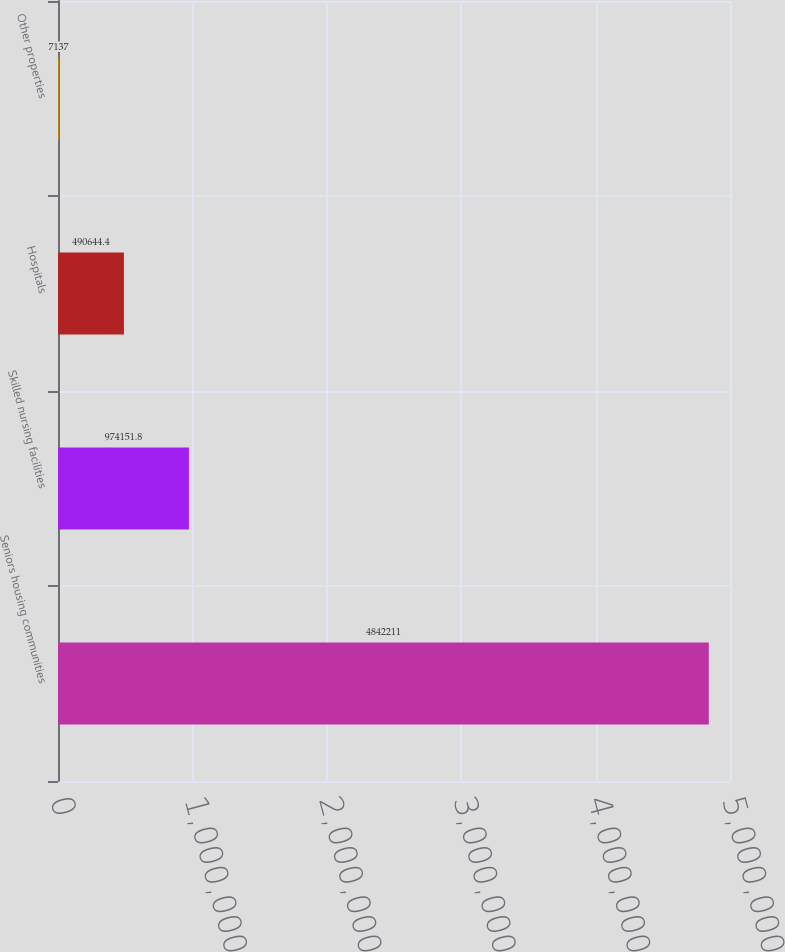<chart> <loc_0><loc_0><loc_500><loc_500><bar_chart><fcel>Seniors housing communities<fcel>Skilled nursing facilities<fcel>Hospitals<fcel>Other properties<nl><fcel>4.84221e+06<fcel>974152<fcel>490644<fcel>7137<nl></chart> 